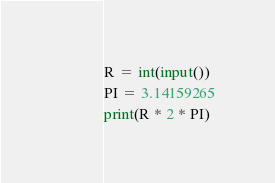Convert code to text. <code><loc_0><loc_0><loc_500><loc_500><_Python_>R = int(input())
PI = 3.14159265
print(R * 2 * PI)</code> 